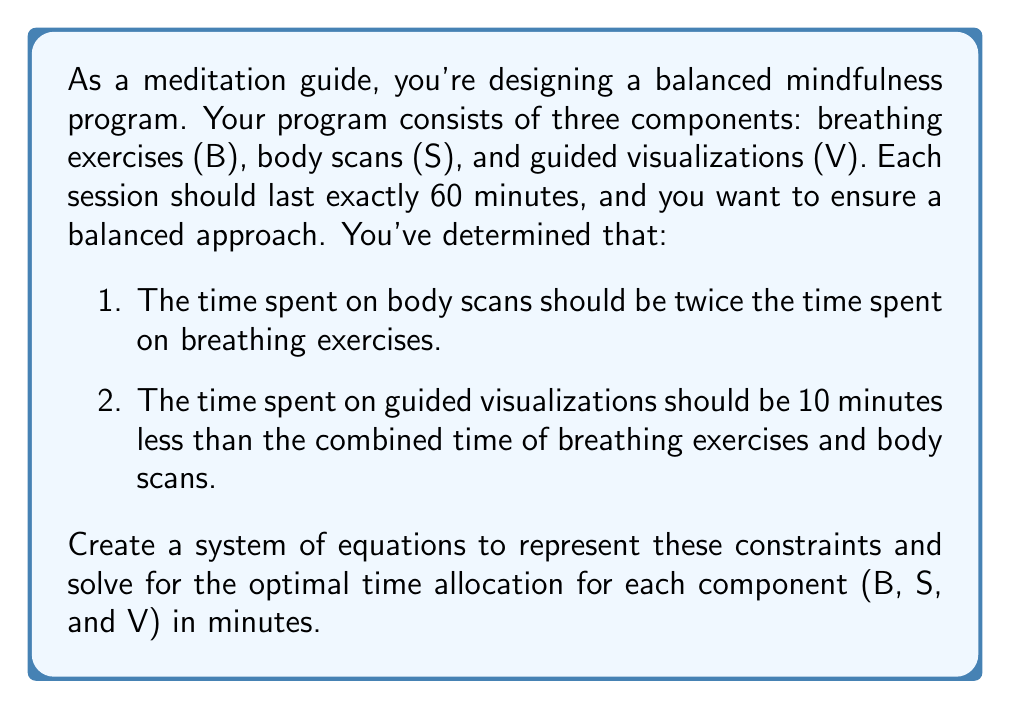Can you answer this question? Let's approach this step-by-step:

1) First, let's define our variables:
   B = time spent on breathing exercises (in minutes)
   S = time spent on body scans (in minutes)
   V = time spent on guided visualizations (in minutes)

2) Now, let's translate the given information into equations:
   - Total time: $B + S + V = 60$
   - Body scans are twice breathing exercises: $S = 2B$
   - Guided visualizations are 10 minutes less than breathing exercises and body scans combined: $V = B + S - 10$

3) We now have a system of three equations:
   $$\begin{cases}
   B + S + V = 60 \\
   S = 2B \\
   V = B + S - 10
   \end{cases}$$

4) Let's substitute the second equation into the first and third:
   $$\begin{cases}
   B + 2B + V = 60 \\
   V = B + 2B - 10
   \end{cases}$$

   Which simplifies to:
   $$\begin{cases}
   3B + V = 60 \\
   V = 3B - 10
   \end{cases}$$

5) Now, let's substitute the second equation into the first:
   $3B + (3B - 10) = 60$

6) Simplify:
   $6B - 10 = 60$
   $6B = 70$
   $B = \frac{70}{6} \approx 11.67$

7) Round B to the nearest whole number: B = 12 minutes

8) Calculate S: $S = 2B = 2(12) = 24$ minutes

9) Calculate V: $V = 60 - B - S = 60 - 12 - 24 = 24$ minutes

Therefore, the optimal time allocation is:
Breathing exercises (B): 12 minutes
Body scans (S): 24 minutes
Guided visualizations (V): 24 minutes
Answer: B = 12, S = 24, V = 24 (in minutes) 